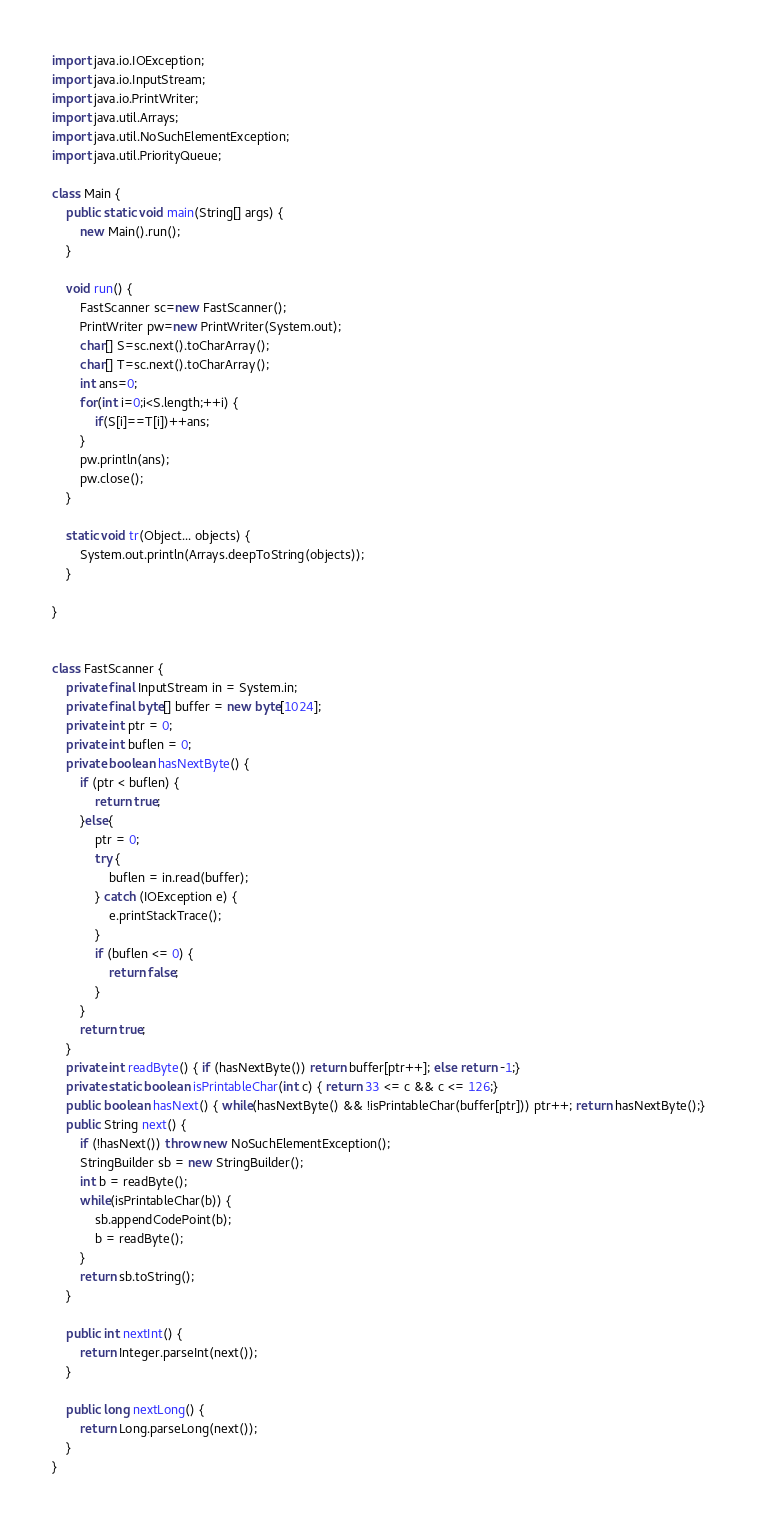<code> <loc_0><loc_0><loc_500><loc_500><_Java_>import java.io.IOException;
import java.io.InputStream;
import java.io.PrintWriter;
import java.util.Arrays;
import java.util.NoSuchElementException;
import java.util.PriorityQueue;

class Main {
	public static void main(String[] args) {
		new Main().run();
	}
	
	void run() {
		FastScanner sc=new FastScanner();
		PrintWriter pw=new PrintWriter(System.out);
		char[] S=sc.next().toCharArray();
		char[] T=sc.next().toCharArray();
		int ans=0;
		for(int i=0;i<S.length;++i) {
			if(S[i]==T[i])++ans;
		}
		pw.println(ans);
		pw.close();
	}
	
	static void tr(Object... objects) {
		System.out.println(Arrays.deepToString(objects));
	}

}


class FastScanner {
    private final InputStream in = System.in;
    private final byte[] buffer = new byte[1024];
    private int ptr = 0;
    private int buflen = 0;
    private boolean hasNextByte() {
        if (ptr < buflen) {
            return true;
        }else{
            ptr = 0;
            try {
                buflen = in.read(buffer);
            } catch (IOException e) {
                e.printStackTrace();
            }
            if (buflen <= 0) {
                return false;
            }
        }
        return true;
    }
    private int readByte() { if (hasNextByte()) return buffer[ptr++]; else return -1;}
    private static boolean isPrintableChar(int c) { return 33 <= c && c <= 126;}
    public boolean hasNext() { while(hasNextByte() && !isPrintableChar(buffer[ptr])) ptr++; return hasNextByte();}
    public String next() {
        if (!hasNext()) throw new NoSuchElementException();
        StringBuilder sb = new StringBuilder();
        int b = readByte();
        while(isPrintableChar(b)) {
            sb.appendCodePoint(b);
            b = readByte();
        }
        return sb.toString();
    }

    public int nextInt() {
    	return Integer.parseInt(next());
    }
    
    public long nextLong() {
    	return Long.parseLong(next());
    }
}</code> 